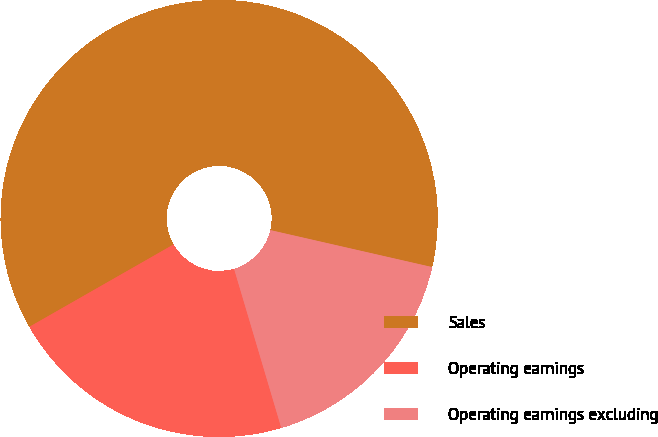<chart> <loc_0><loc_0><loc_500><loc_500><pie_chart><fcel>Sales<fcel>Operating earnings<fcel>Operating earnings excluding<nl><fcel>61.83%<fcel>21.33%<fcel>16.83%<nl></chart> 